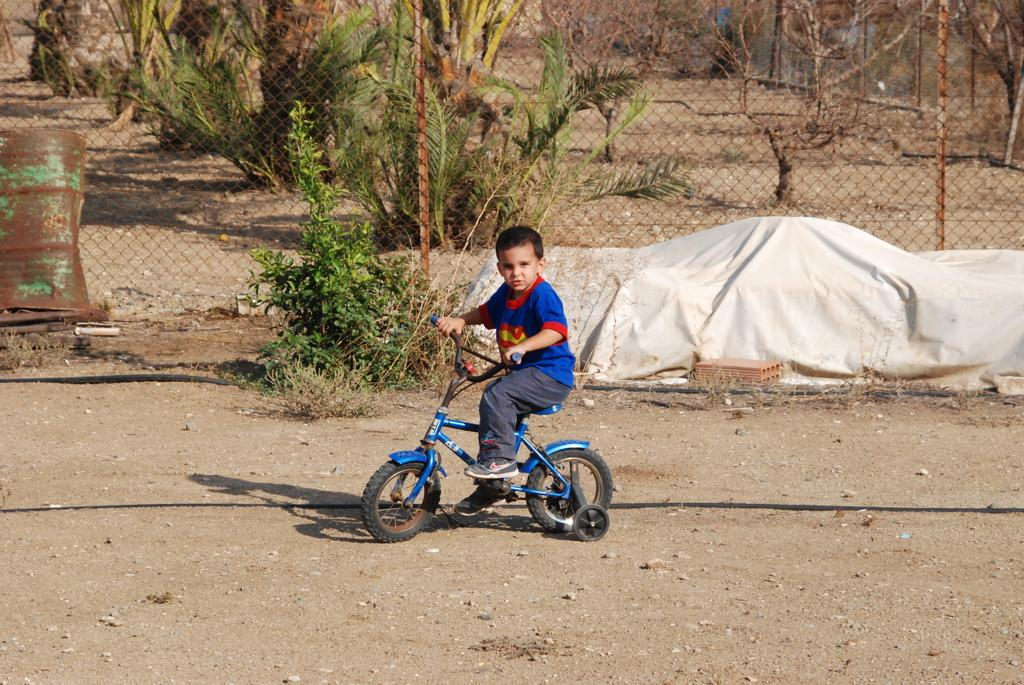What is the main subject of the image? The main subject of the image is a kid. What is the kid wearing in the image? The kid is wearing a blue shirt in the image. What is the kid doing in the image? The kid is riding a blue bicycle in the image. What can be seen in the background of the image? There are trees and a fence in the background of the image. What type of prose is the kid reading while riding the bicycle in the image? There is no indication in the image that the kid is reading any prose while riding the bicycle. 